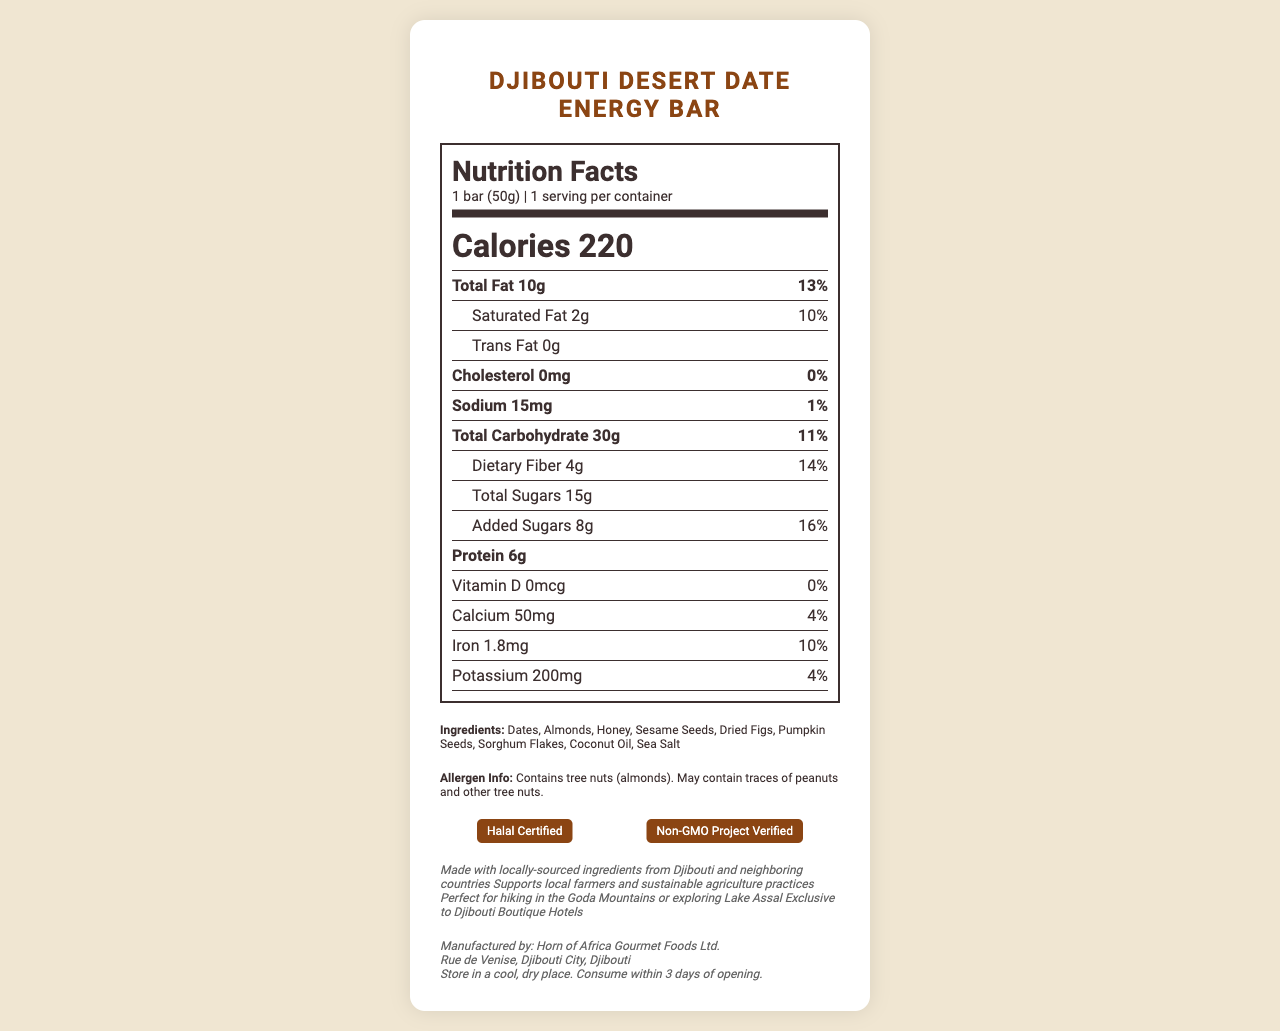what is the serving size? The serving size is explicitly mentioned in the first section of the Nutrition Facts Label.
Answer: 1 bar (50g) how many calories are there per serving? The number of calories per serving is clearly specified in the Nutrition Facts Label.
Answer: 220 what is the total fat content? The total fat content is listed directly under the calories section, with both the amount and the daily value percentage (13%).
Answer: 10g how much protein does the bar contain? The amount of protein is listed towards the bottom of the main nutrient section of the Nutrition Facts Label.
Answer: 6g what percentage of the daily value of iron is in the energy bar? The daily value percentage for iron is listed under the iron amount in the Nutritional Facts section.
Answer: 10% does the energy bar contain any trans fat? The document indicates that the trans fat content is 0g, which means there are no trans fats in the bar.
Answer: No is the energy bar suitable for someone with a nut allergy? The allergen information clearly states that the energy bar contains tree nuts (almonds) and may contain traces of peanuts and other tree nuts.
Answer: No what are the first three ingredients in the energy bar? The ingredients are listed in order of their quantity in the product, with Dates, Almonds, and Honey being the first three.
Answer: Dates, Almonds, Honey Multiple-Choice: which certification does the Djibouti Desert Date Energy Bar have? A. Organic Certified B. Gluten-Free Certified C. Halal Certified D. Fair Trade Certified The label has both Halal Certified and Non-GMO Project Verified certifications, but no mention of organic or gluten-free certifications.
Answer: C. Halal Certified Multiple-Choice: how long should the energy bar be consumed within once opened? 1. 1 day 2. 2 days 3. 3 days 4. 4 days The storage instructions explicitly state that the bar should be consumed within 3 days of opening.
Answer: 3. 3 days is the Djibouti Desert Date Energy Bar GMO-free? The certification section mentions that the product is Non-GMO Project Verified, indicating it is GMO-free.
Answer: Yes can the energy bar be eaten by someone with gluten intolerance? The document does not specify whether the product is gluten-free.
Answer: Cannot be determined summarize the main idea of this document. The label provides comprehensive details about the nutritional value and various other facts related to the product, aimed at informing consumers about what they are consuming and its benefits.
Answer: The document is a Nutrition Facts Label for the Djibouti Desert Date Energy Bar, detailing its nutritional content per serving, ingredients, allergen information, certifications, storage instructions, and additional information about sourcing and benefits. 